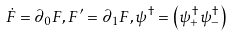Convert formula to latex. <formula><loc_0><loc_0><loc_500><loc_500>\dot { F } = \partial _ { 0 } F , F { ^ { \prime } } = \partial _ { 1 } F , \psi ^ { \dag } = \left ( \psi _ { + } ^ { \dag } \psi _ { - } ^ { \dag } \right )</formula> 